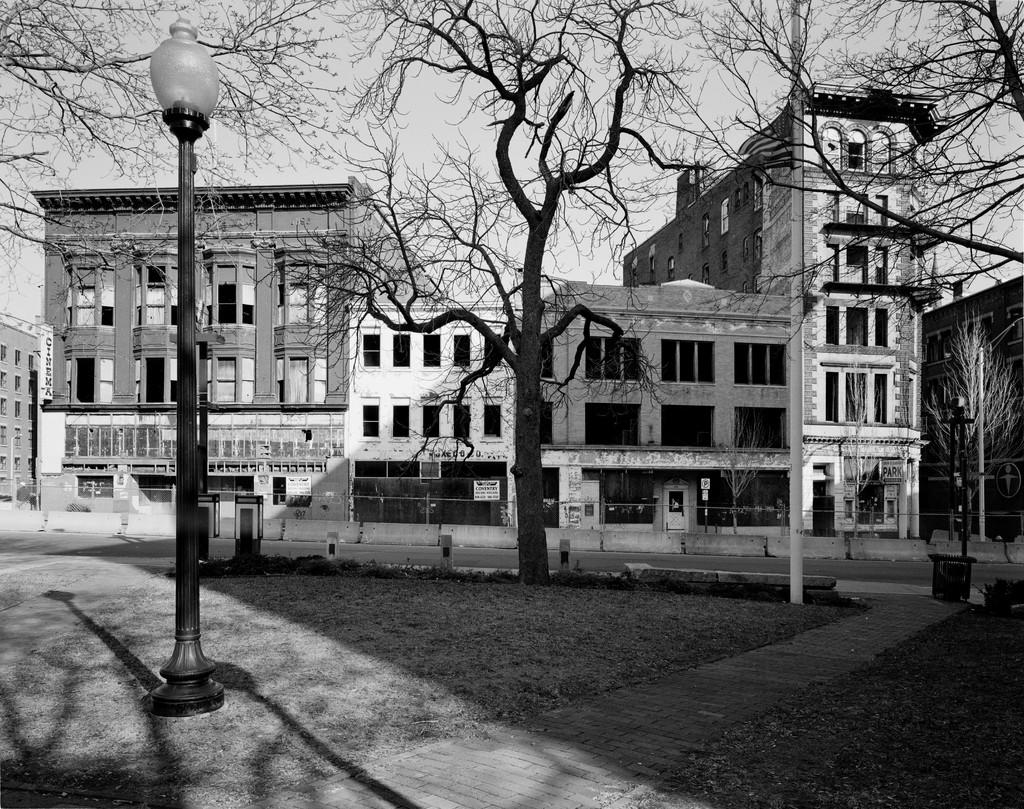What structure can be seen in the image? There is a light pole in the image. What can be seen in the background of the image? There are dried trees and buildings in the background of the image. What is visible in the sky in the image? The sky is visible in the background of the image. How is the image presented in terms of color? The image is in black and white. How many gloves are being folded in the image? There are no gloves present in the image, and therefore no folding activity can be observed. 